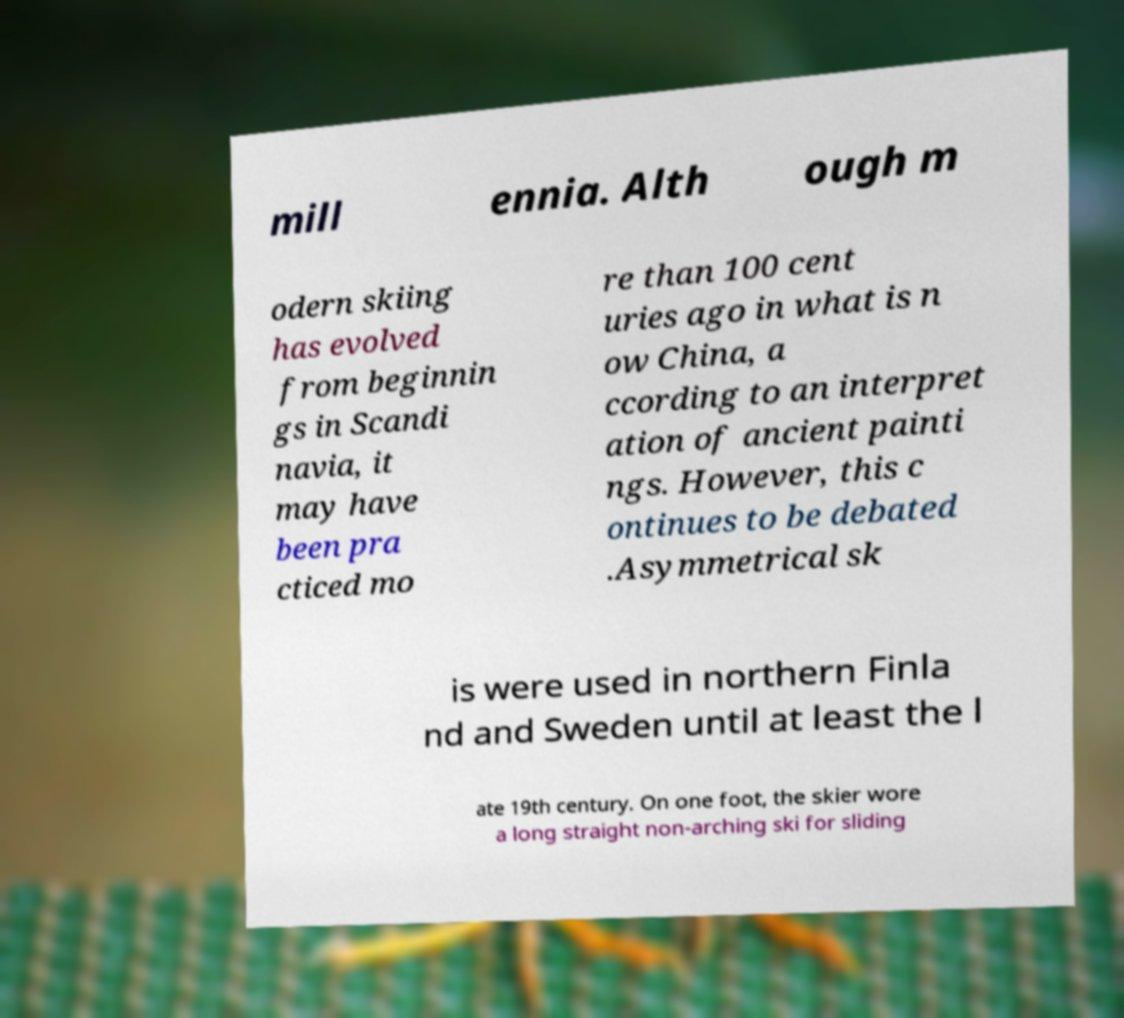There's text embedded in this image that I need extracted. Can you transcribe it verbatim? mill ennia. Alth ough m odern skiing has evolved from beginnin gs in Scandi navia, it may have been pra cticed mo re than 100 cent uries ago in what is n ow China, a ccording to an interpret ation of ancient painti ngs. However, this c ontinues to be debated .Asymmetrical sk is were used in northern Finla nd and Sweden until at least the l ate 19th century. On one foot, the skier wore a long straight non-arching ski for sliding 